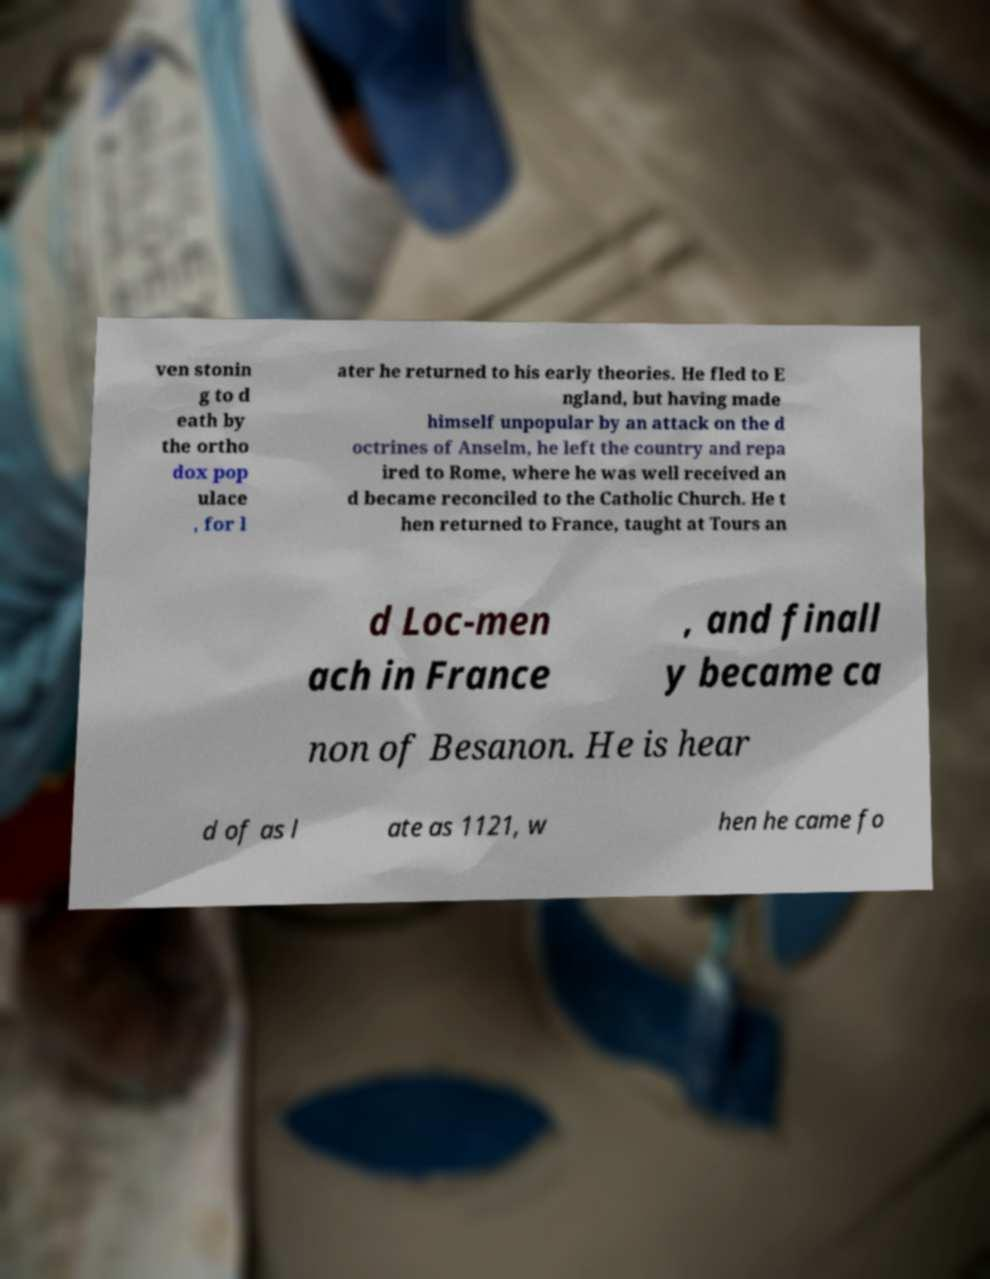Could you extract and type out the text from this image? ven stonin g to d eath by the ortho dox pop ulace , for l ater he returned to his early theories. He fled to E ngland, but having made himself unpopular by an attack on the d octrines of Anselm, he left the country and repa ired to Rome, where he was well received an d became reconciled to the Catholic Church. He t hen returned to France, taught at Tours an d Loc-men ach in France , and finall y became ca non of Besanon. He is hear d of as l ate as 1121, w hen he came fo 